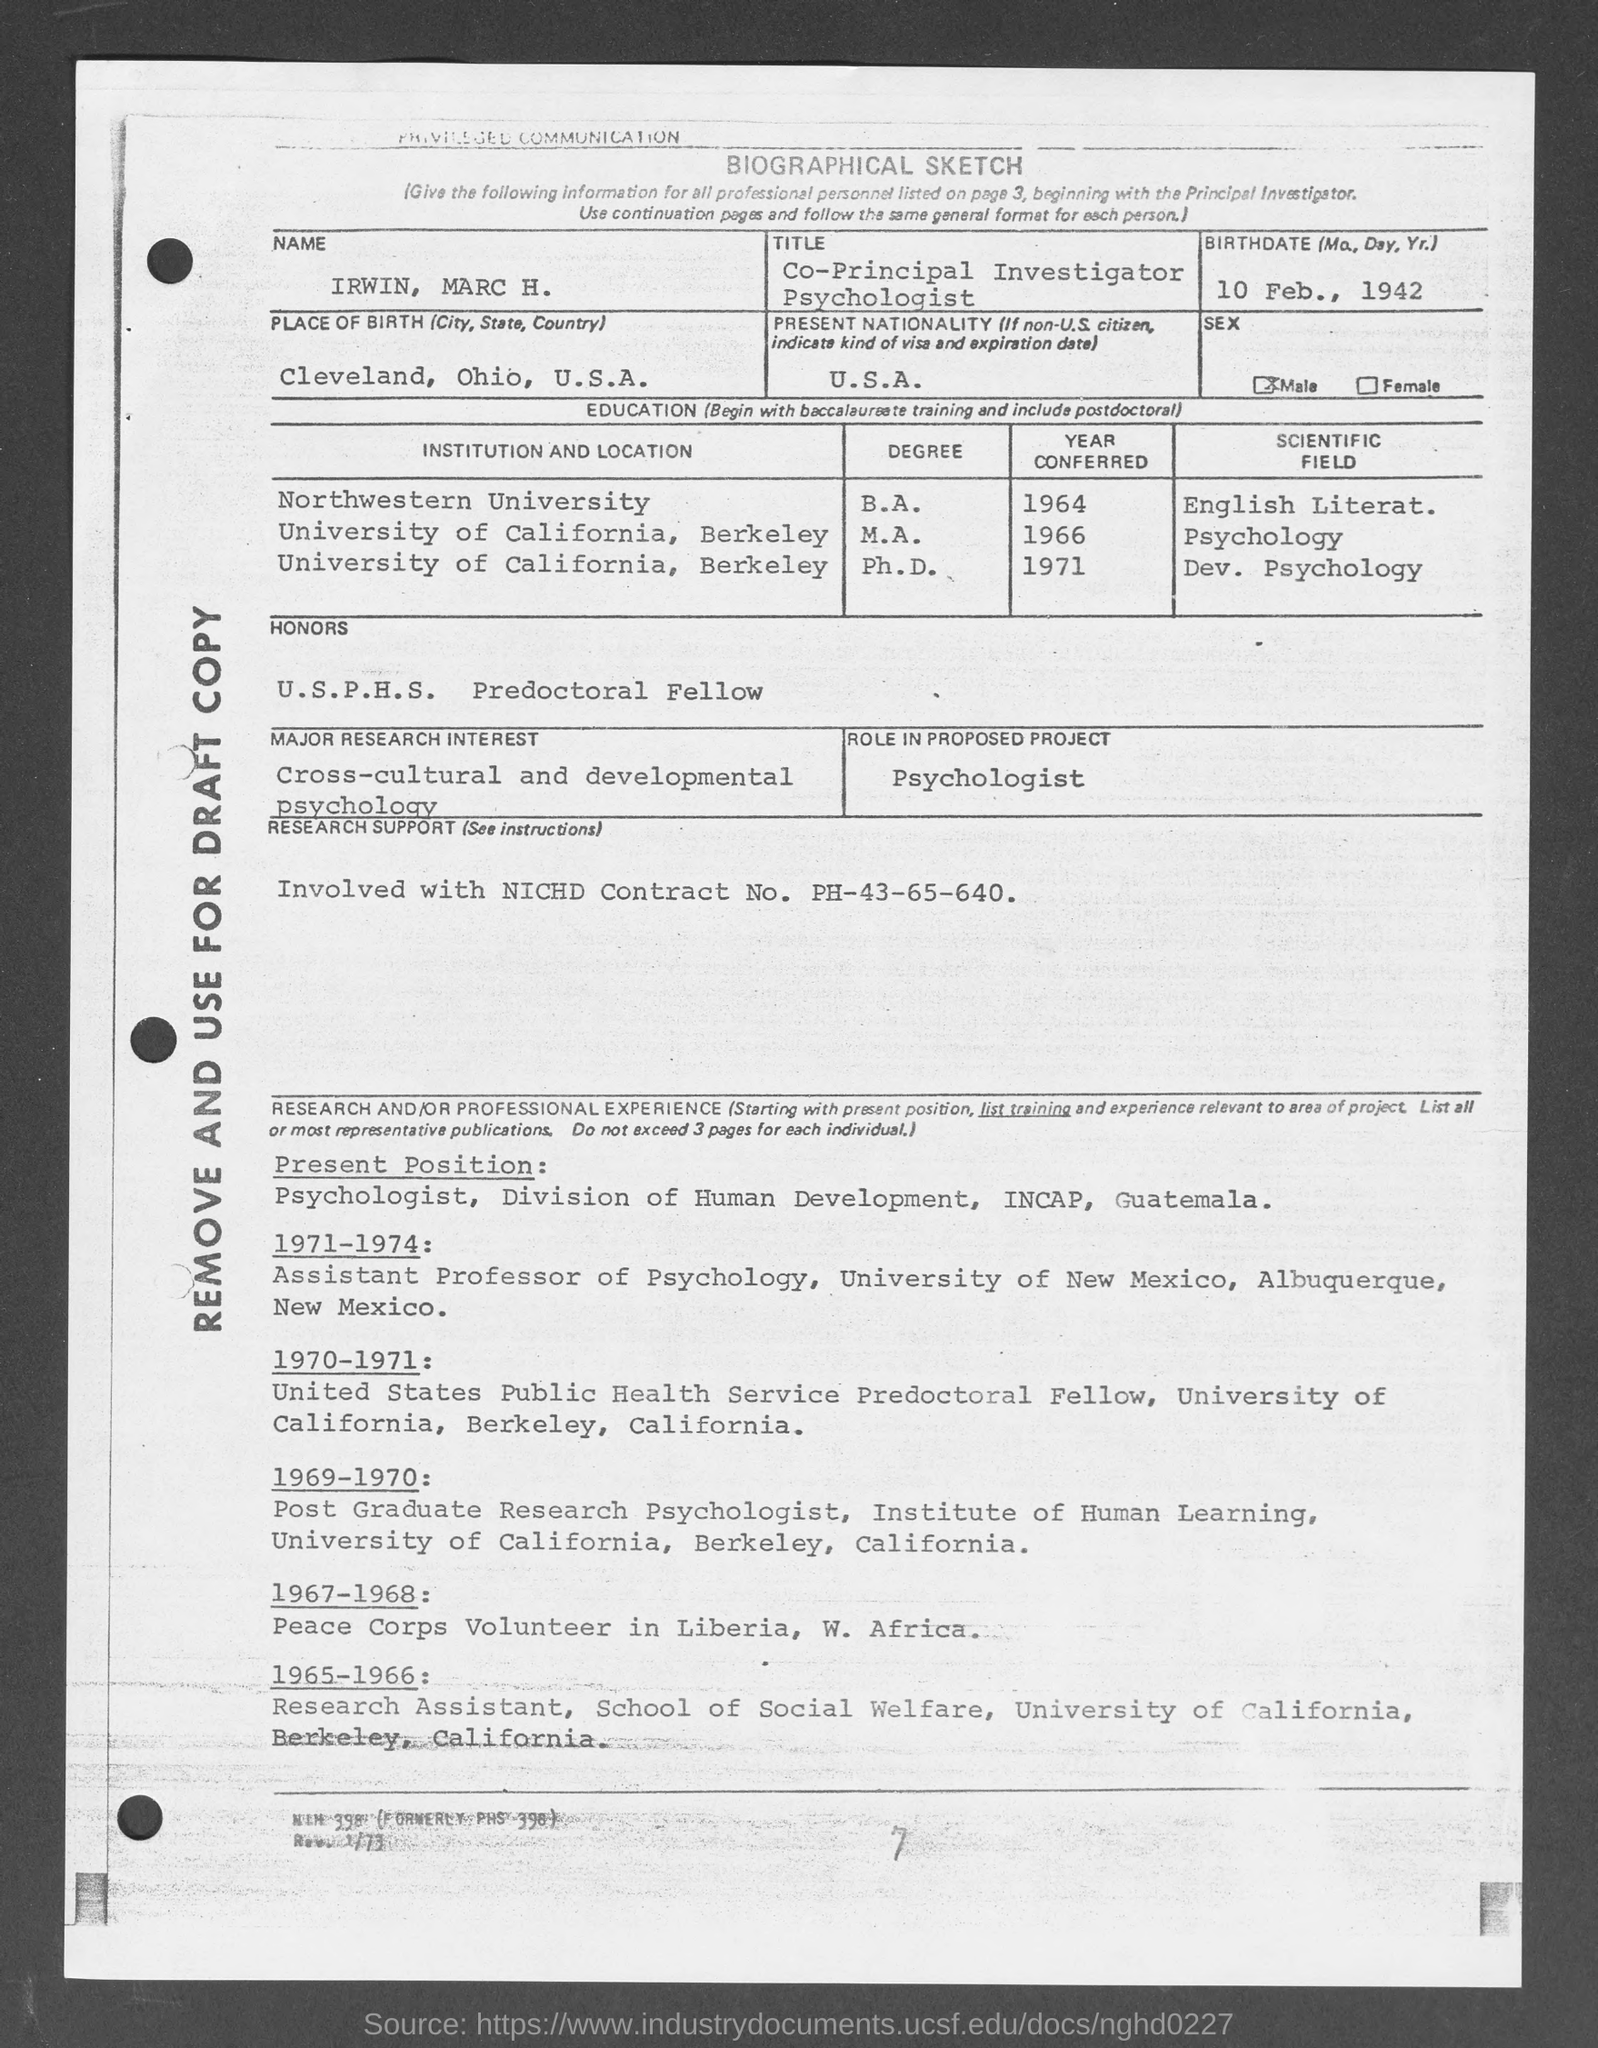What form is this?
Provide a succinct answer. Biographical sketch. What is Irwin's title?
Keep it short and to the point. Co-principal investigator psychologist. What is Irwin's birthdate?
Your answer should be compact. 10 Feb., 1942. What is Irwin's present nationality?
Make the answer very short. U.S.A. What are Irwin's honors mentioned?
Make the answer very short. U.S.P.H.S. Predoctoral Fellow. What is the major research interest mentioned?
Offer a very short reply. Cross-cultural and developmental psychology. What is the role in proposed project?
Your response must be concise. Psychologist. What is the research support?
Make the answer very short. Involved with nichd contract no. ph-43-65-640. 